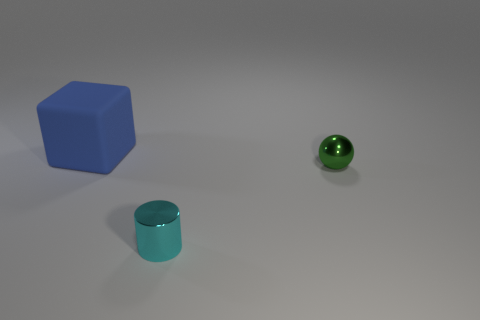Add 2 small green shiny spheres. How many objects exist? 5 Subtract all balls. How many objects are left? 2 Subtract 0 yellow balls. How many objects are left? 3 Subtract all green shiny things. Subtract all big yellow spheres. How many objects are left? 2 Add 3 cyan metal objects. How many cyan metal objects are left? 4 Add 2 big blue matte things. How many big blue matte things exist? 3 